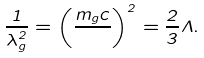Convert formula to latex. <formula><loc_0><loc_0><loc_500><loc_500>\frac { 1 } { \lambda _ { g } ^ { 2 } } = \left ( \frac { m _ { g } c } { } \right ) ^ { 2 } = \frac { 2 } { 3 } \Lambda .</formula> 